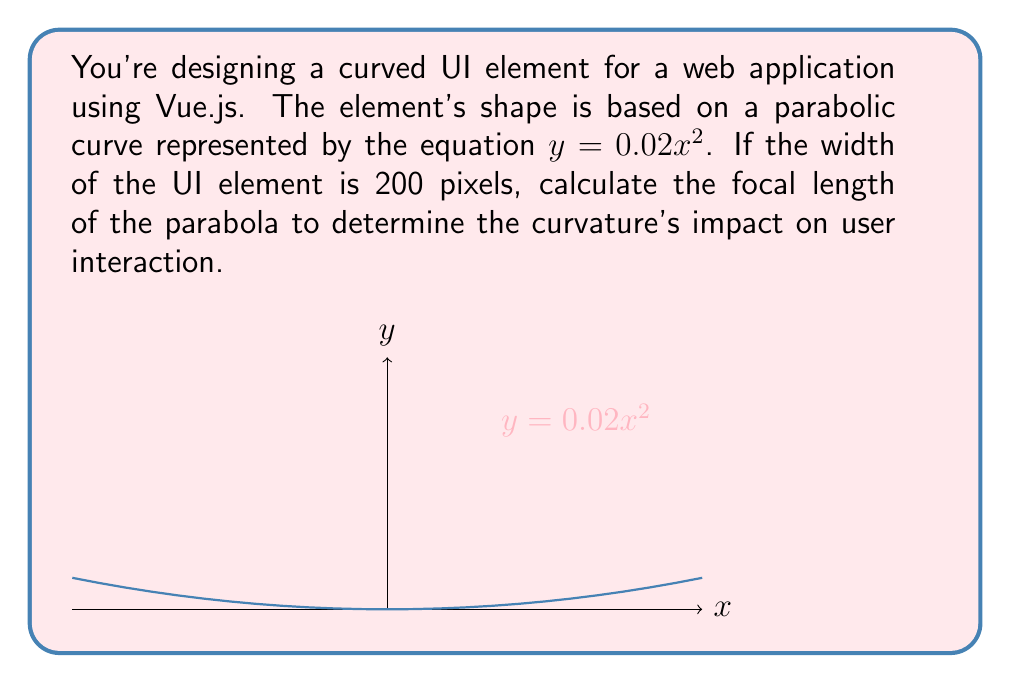Could you help me with this problem? Let's approach this step-by-step:

1) The general form of a parabola with vertex at the origin is:

   $$y = ax^2$$

   where $a$ is the coefficient of $x^2$.

2) In our case, $a = 0.02$, so our parabola equation is:

   $$y = 0.02x^2$$

3) The focal length of a parabola is given by the formula:

   $$f = \frac{1}{4a}$$

   where $f$ is the focal length and $a$ is the coefficient of $x^2$ in the parabola equation.

4) Substituting our value of $a$:

   $$f = \frac{1}{4(0.02)} = \frac{1}{0.08}$$

5) Simplifying:

   $$f = 12.5$$

6) Since the width of the UI element is 200 pixels, and the parabola is symmetric, the x-coordinate ranges from -100 to 100.

7) The focal length of 12.5 pixels means that the focus of the parabola is 12.5 pixels above the vertex (which is at the origin in this case).

This focal length determines how "curved" the UI element appears. A smaller focal length would result in a more pronounced curve, while a larger focal length would make the curve more gradual.
Answer: 12.5 pixels 